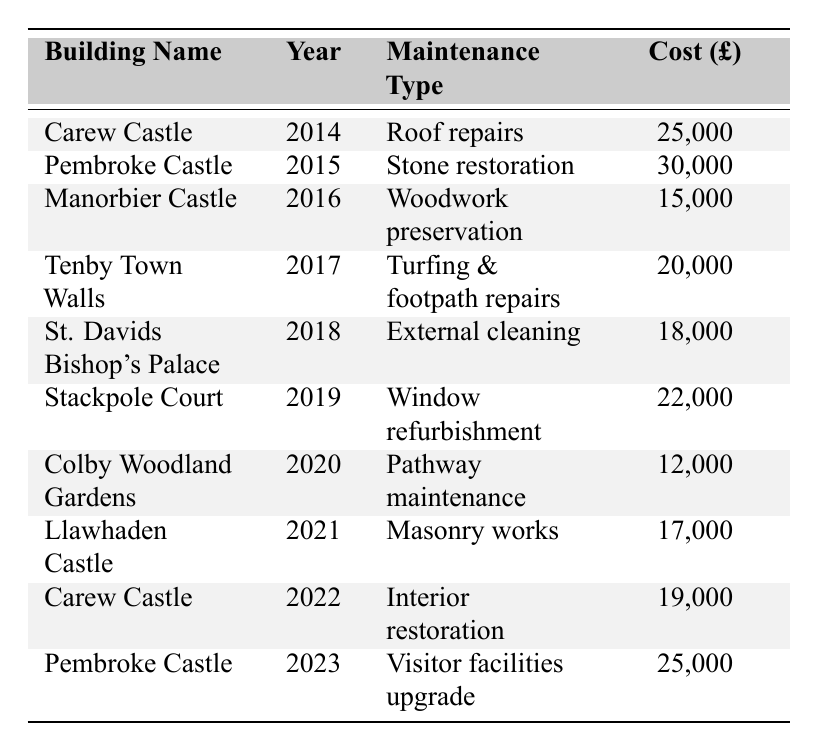What was the maintenance type for Carew Castle in 2014? The table shows that the maintenance type for Carew Castle in 2014 is roof repairs.
Answer: Roof repairs Which building had the highest maintenance cost and what was it for? By checking the values in the table, Pembroke Castle in 2015 had the highest maintenance cost of £30,000 for stone restoration.
Answer: Pembroke Castle, stone restoration How much was spent on masonry works in Llawhaden Castle? The table lists Llawhaden Castle's maintenance cost for masonry works in 2021 as £17,000.
Answer: £17,000 What was the total maintenance cost for Carew Castle over the years listed? The costs for Carew Castle are £25,000 (2014) + £19,000 (2022) = £44,000. Therefore, the total for Carew Castle over these years is £44,000.
Answer: £44,000 Was the maintenance cost for St. Davids Bishop's Palace higher in 2018 than that for Colby Woodland Gardens in 2020? The cost for St. Davids Bishop's Palace in 2018 was £18,000, and for Colby Woodland Gardens in 2020, it was £12,000. Since £18,000 is greater than £12,000, the answer is yes.
Answer: Yes What is the average maintenance cost across all buildings for the years provided? The total maintenance cost sums up to £25,000 + £30,000 + £15,000 + £20,000 + £18,000 + £22,000 + £12,000 + £17,000 + £19,000 + £25,000 = £193,000. There are 10 values resulting in an average of £193,000 / 10 = £19,300.
Answer: £19,300 Which year saw the least amount spent on maintenance and what was the building? The lowest maintenance cost is £12,000 in 2020 for Colby Woodland Gardens.
Answer: 2020, Colby Woodland Gardens How much did Pembroke Castle spend on maintenance in total over the years listed? Pembroke Castle's costs are £30,000 (2015) + £25,000 (2023) = £55,000. So, the total maintenance expenditure for Pembroke Castle over these years is £55,000.
Answer: £55,000 Did any building have maintenance costs above £20,000 in two different years? The only building that had expenses above £20,000 in two different years is Pembroke Castle, spending £30,000 in 2015 and £25,000 in 2023.
Answer: Yes Which building had the second lowest maintenance expenditure and what was the amount? The second lowest expenditure is for Llawhaden Castle in 2021 at £17,000, after Colby Woodland Gardens at £12,000.
Answer: Llawhaden Castle, £17,000 